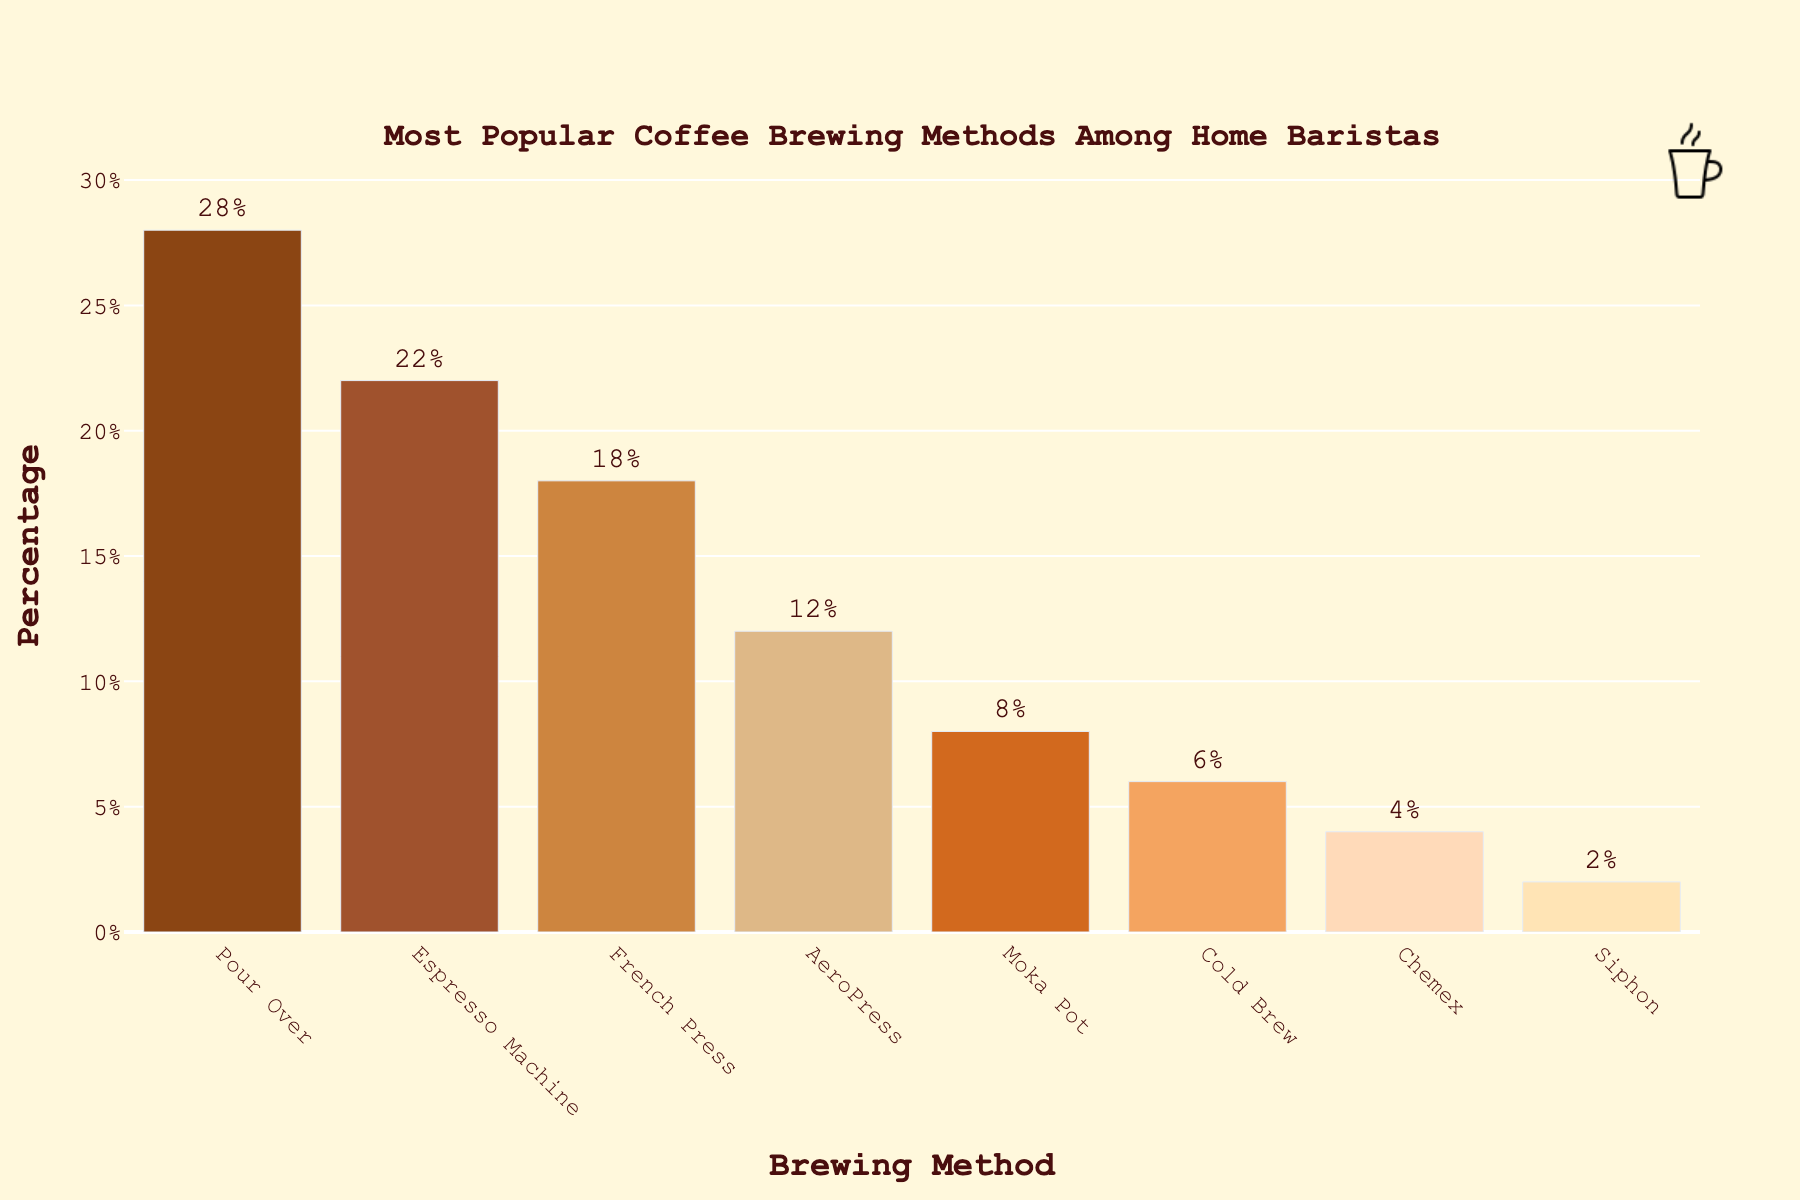What is the most popular coffee brewing method among home baristas? The most popular method is easily identified by the tallest bar in the chart. The Pour Over method has the tallest bar at 28%.
Answer: Pour Over What is the combined percentage of people using Cold Brew, Chemex, and Siphon methods? Sum the percentages of Cold Brew (6%), Chemex (4%), and Siphon (2%): 6 + 4 + 2 = 12%.
Answer: 12% Which coffee brewing method is more popular, AeroPress or Moka Pot? Compare the heights of the AeroPress bar (12%) and the Moka Pot bar (8%); AeroPress has a higher percentage.
Answer: AeroPress What is the difference in popularity between the Espresso Machine and French Press methods? Subtract the percentage of French Press (18%) from that of Espresso Machine (22%): 22 - 18 = 4%.
Answer: 4% How much more popular is the Pour Over method compared to the Cold Brew method? Subtract the percentage of Cold Brew (6%) from that of Pour Over (28%): 28 - 6 = 22%.
Answer: 22% What is the least popular coffee brewing method? The least popular method can be identified by the shortest bar, which is Siphon at 2%.
Answer: Siphon How many brewing methods are used by more than 10% of home baristas? Count the methods with percentages greater than 10%: Pour Over (28%), Espresso Machine (22%), French Press (18%), AeroPress (12%). There are 4 such methods.
Answer: 4 By how much does the percentage of Espresso Machine users exceed that of Moka Pot users? Subtract the percentage of Moka Pot (8%) from that of Espresso Machine (22%): 22 - 8 = 14%.
Answer: 14% Which method has a percentage closest to 20%? The method with a percentage closest to 20% is the Espresso Machine at 22%.
Answer: Espresso Machine What is the average percentage of the top three most popular brewing methods? Sum the percentages of Pour Over (28%), Espresso Machine (22%), and French Press (18%) and then divide by 3: (28 + 22 + 18) / 3 = 68 / 3 ≈ 22.67%.
Answer: 22.67% 